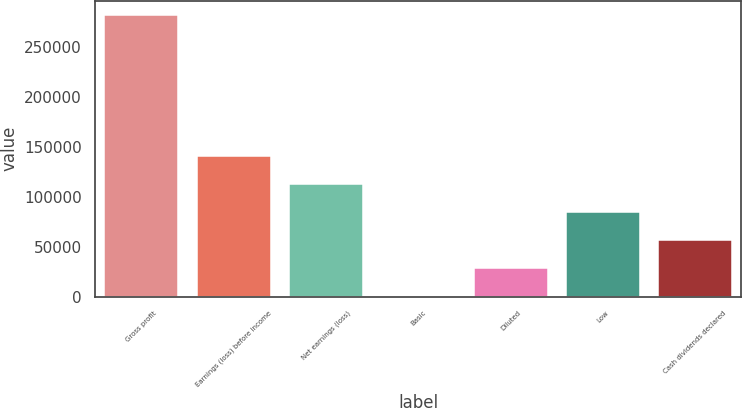<chart> <loc_0><loc_0><loc_500><loc_500><bar_chart><fcel>Gross profit<fcel>Earnings (loss) before income<fcel>Net earnings (loss)<fcel>Basic<fcel>Diluted<fcel>Low<fcel>Cash dividends declared<nl><fcel>282089<fcel>141045<fcel>112836<fcel>0.03<fcel>28208.9<fcel>84626.7<fcel>56417.8<nl></chart> 